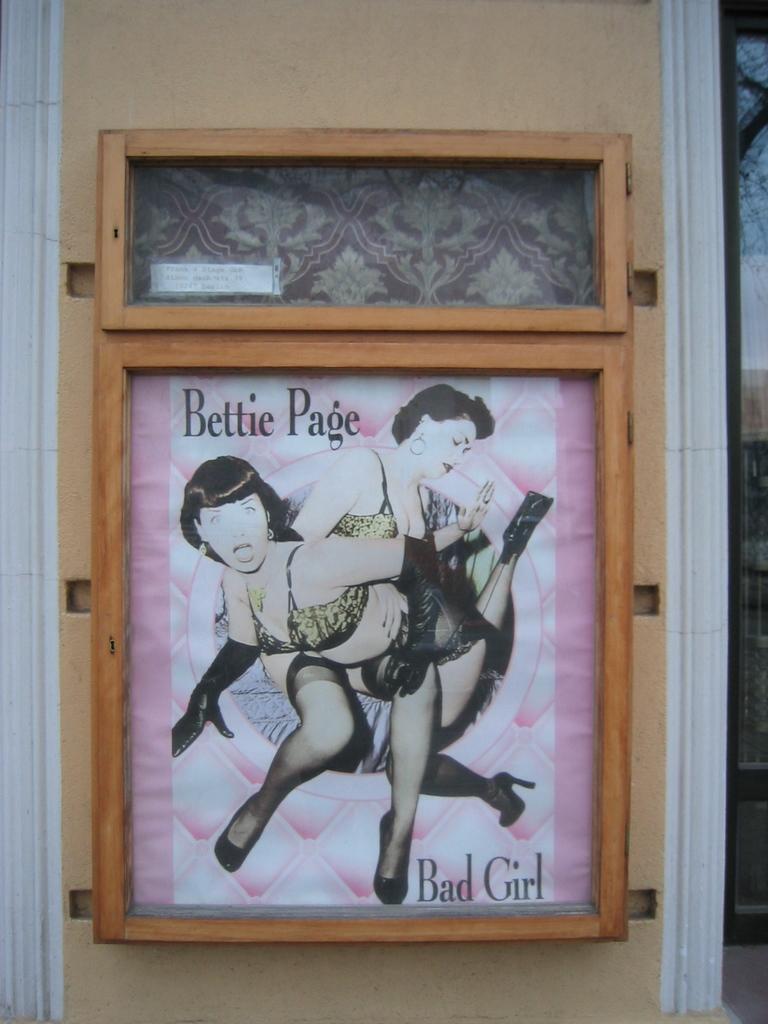Who is bad?
Offer a terse response. Bettie page. Bettie is a bad what?
Ensure brevity in your answer.  Girl. 